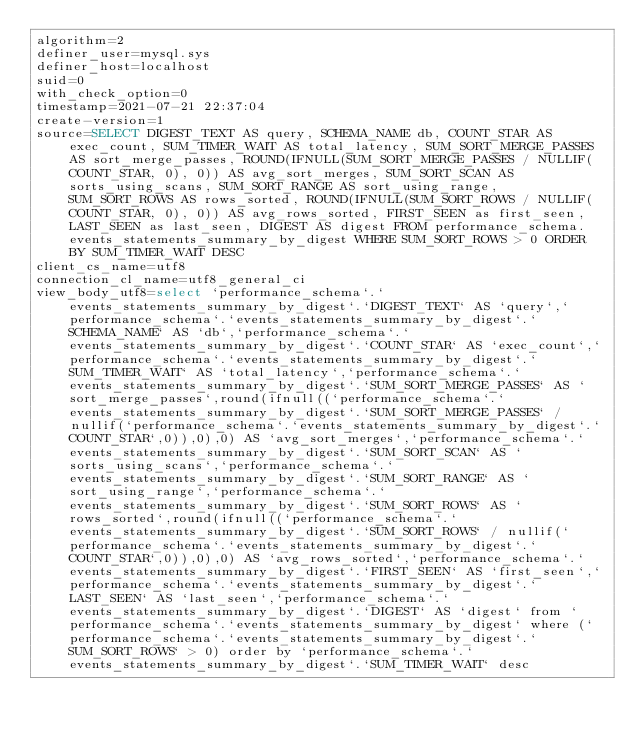<code> <loc_0><loc_0><loc_500><loc_500><_VisualBasic_>algorithm=2
definer_user=mysql.sys
definer_host=localhost
suid=0
with_check_option=0
timestamp=2021-07-21 22:37:04
create-version=1
source=SELECT DIGEST_TEXT AS query, SCHEMA_NAME db, COUNT_STAR AS exec_count, SUM_TIMER_WAIT AS total_latency, SUM_SORT_MERGE_PASSES AS sort_merge_passes, ROUND(IFNULL(SUM_SORT_MERGE_PASSES / NULLIF(COUNT_STAR, 0), 0)) AS avg_sort_merges, SUM_SORT_SCAN AS sorts_using_scans, SUM_SORT_RANGE AS sort_using_range, SUM_SORT_ROWS AS rows_sorted, ROUND(IFNULL(SUM_SORT_ROWS / NULLIF(COUNT_STAR, 0), 0)) AS avg_rows_sorted, FIRST_SEEN as first_seen, LAST_SEEN as last_seen, DIGEST AS digest FROM performance_schema.events_statements_summary_by_digest WHERE SUM_SORT_ROWS > 0 ORDER BY SUM_TIMER_WAIT DESC
client_cs_name=utf8
connection_cl_name=utf8_general_ci
view_body_utf8=select `performance_schema`.`events_statements_summary_by_digest`.`DIGEST_TEXT` AS `query`,`performance_schema`.`events_statements_summary_by_digest`.`SCHEMA_NAME` AS `db`,`performance_schema`.`events_statements_summary_by_digest`.`COUNT_STAR` AS `exec_count`,`performance_schema`.`events_statements_summary_by_digest`.`SUM_TIMER_WAIT` AS `total_latency`,`performance_schema`.`events_statements_summary_by_digest`.`SUM_SORT_MERGE_PASSES` AS `sort_merge_passes`,round(ifnull((`performance_schema`.`events_statements_summary_by_digest`.`SUM_SORT_MERGE_PASSES` / nullif(`performance_schema`.`events_statements_summary_by_digest`.`COUNT_STAR`,0)),0),0) AS `avg_sort_merges`,`performance_schema`.`events_statements_summary_by_digest`.`SUM_SORT_SCAN` AS `sorts_using_scans`,`performance_schema`.`events_statements_summary_by_digest`.`SUM_SORT_RANGE` AS `sort_using_range`,`performance_schema`.`events_statements_summary_by_digest`.`SUM_SORT_ROWS` AS `rows_sorted`,round(ifnull((`performance_schema`.`events_statements_summary_by_digest`.`SUM_SORT_ROWS` / nullif(`performance_schema`.`events_statements_summary_by_digest`.`COUNT_STAR`,0)),0),0) AS `avg_rows_sorted`,`performance_schema`.`events_statements_summary_by_digest`.`FIRST_SEEN` AS `first_seen`,`performance_schema`.`events_statements_summary_by_digest`.`LAST_SEEN` AS `last_seen`,`performance_schema`.`events_statements_summary_by_digest`.`DIGEST` AS `digest` from `performance_schema`.`events_statements_summary_by_digest` where (`performance_schema`.`events_statements_summary_by_digest`.`SUM_SORT_ROWS` > 0) order by `performance_schema`.`events_statements_summary_by_digest`.`SUM_TIMER_WAIT` desc
</code> 